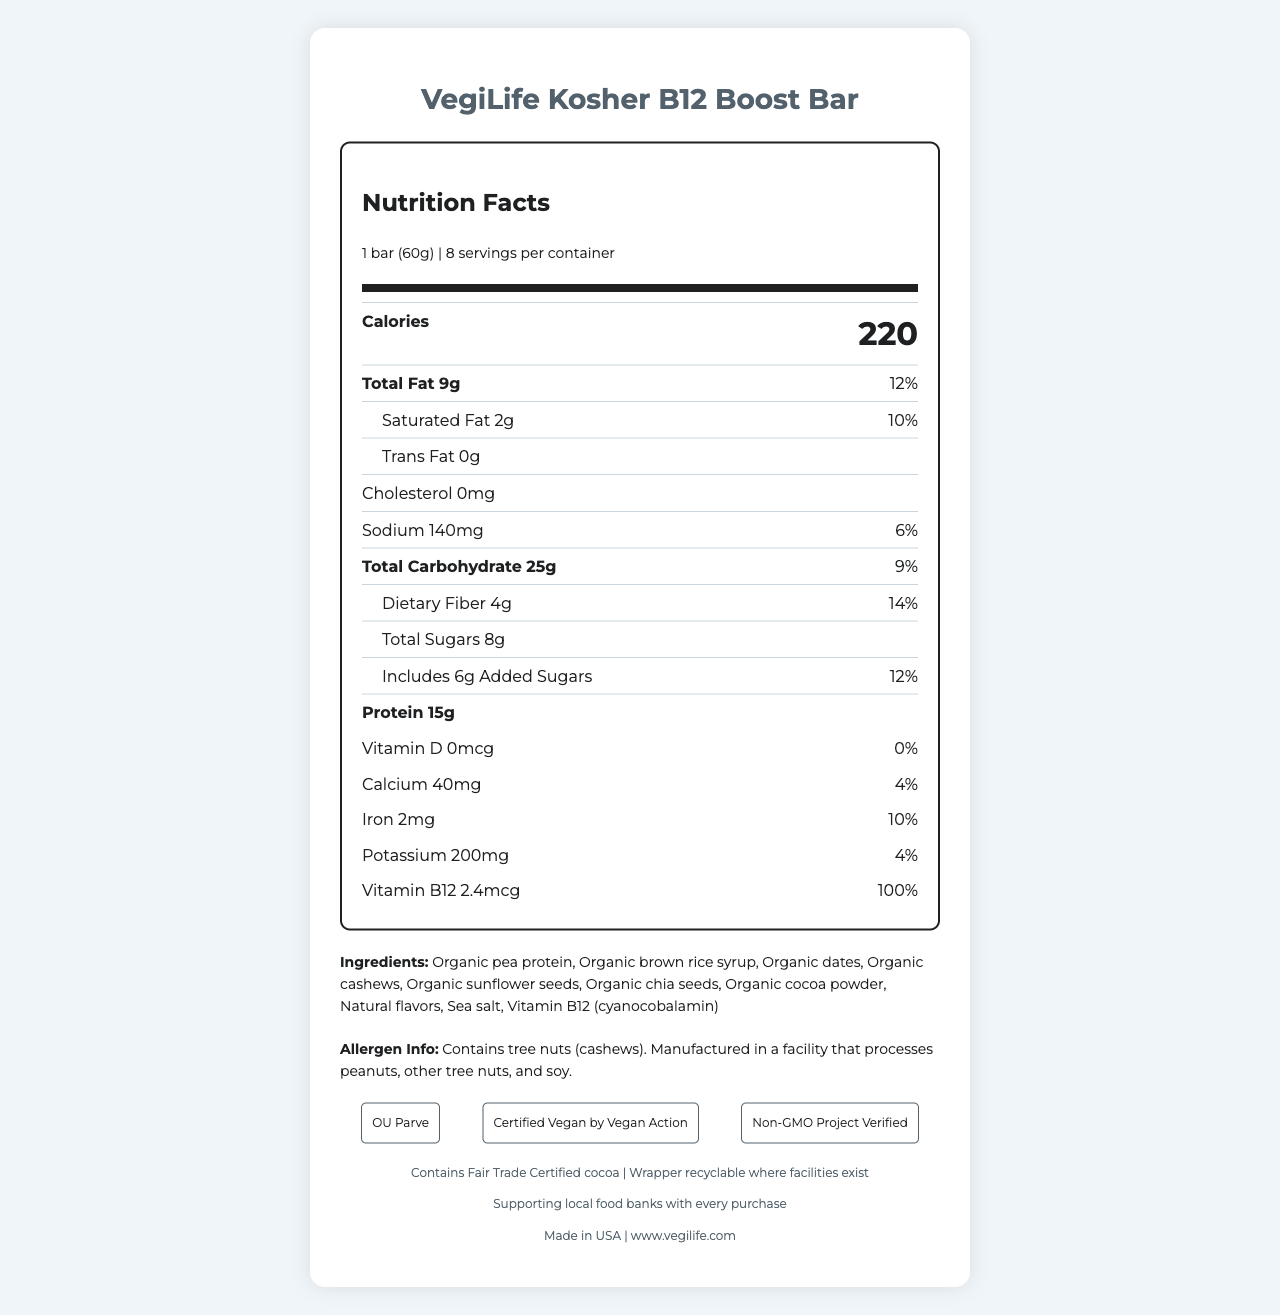what is the serving size of the VegiLife Kosher B12 Boost Bar? The serving size is explicitly stated as "1 bar (60g)" on the document.
Answer: 1 bar (60g) how many calories are there in one serving of the VegiLife Kosher B12 Boost Bar? The calorie count per serving is directly listed as 220 calories.
Answer: 220 calories what is the total fat content in one VegiLife Kosher B12 Boost Bar? The total fat is specified as 9g.
Answer: 9g what is the amount of added sugars in one serving? The amount of added sugars is displayed as 6g.
Answer: 6g what certification denotes the product is kosher? The kosher certification is specified as OU Parve in the document.
Answer: OU Parve does the product contain any tree nuts? The allergen information mentions that the product contains tree nuts (cashews).
Answer: Yes what percentage of daily value of dietary fiber does the bar provide? The daily value percentage for dietary fiber is listed as 14%.
Answer: 14% how much protein does the bar contain? The amount of protein is specified as 15g.
Answer: 15g is the product certified vegan? The document states that it is "Certified Vegan by Vegan Action."
Answer: Yes where is the product manufactured? The manufacturing location is listed as Made in USA.
Answer: Made in USA how many servings are there per container? The servings per container are explicitly stated as 8.
Answer: 8 servings which vitamin in the bar has the highest percentage of daily value? A. Vitamin D B. Calcium C. Iron D. Vitamin B12 Vitamin B12 has 100% of the daily value, which is the highest among the vitamins listed.
Answer: D. Vitamin B12 which certification indicates that the product is non-GMO? I. OU Parve II. Certified Vegan III. Non-GMO Project Verified IV. Fair Trade Certified The Non-GMO statement is given as "Non-GMO Project Verified."
Answer: III. Non-GMO Project Verified how much sodium does one bar contain? The sodium content per serving is shown as 140mg.
Answer: 140mg is there any cholesterol present in the bar? The document states that the cholesterol amount is 0mg.
Answer: No what is the company mission mentioned on the document? The company mission is described as "Supporting local food banks with every purchase."
Answer: Supporting local food banks with every purchase are there dates as one of the ingredients in the bar? "Organic dates" are listed as an ingredient.
Answer: Yes is the wrapper recyclable? The document states, "Wrapper recyclable where facilities exist."
Answer: Yes does the bar contain any animal-derived ingredients? The bar is certified vegan, indicating it contains no animal-derived ingredients.
Answer: No provide a summary of the document. The summary includes the product name, nutritional details, certifications, allergen information, company mission, manufacturing location, and website.
Answer: The document is a Nutrition Facts Label for the VegiLife Kosher B12 Boost Bar. It includes information on serving size, calories, various nutrient contents, and daily values. It lists the ingredients, allergen information, certifications for being kosher, vegan, non-GMO, and fair trade. The label also mentions the company's mission to support local food banks, the product's manufacturing location, and its website. what is the source of Vitamin B12 in the bar? The document does not specify the source of Vitamin B12 beyond stating it's included (cyanocobalamin).
Answer: Cannot be determined 